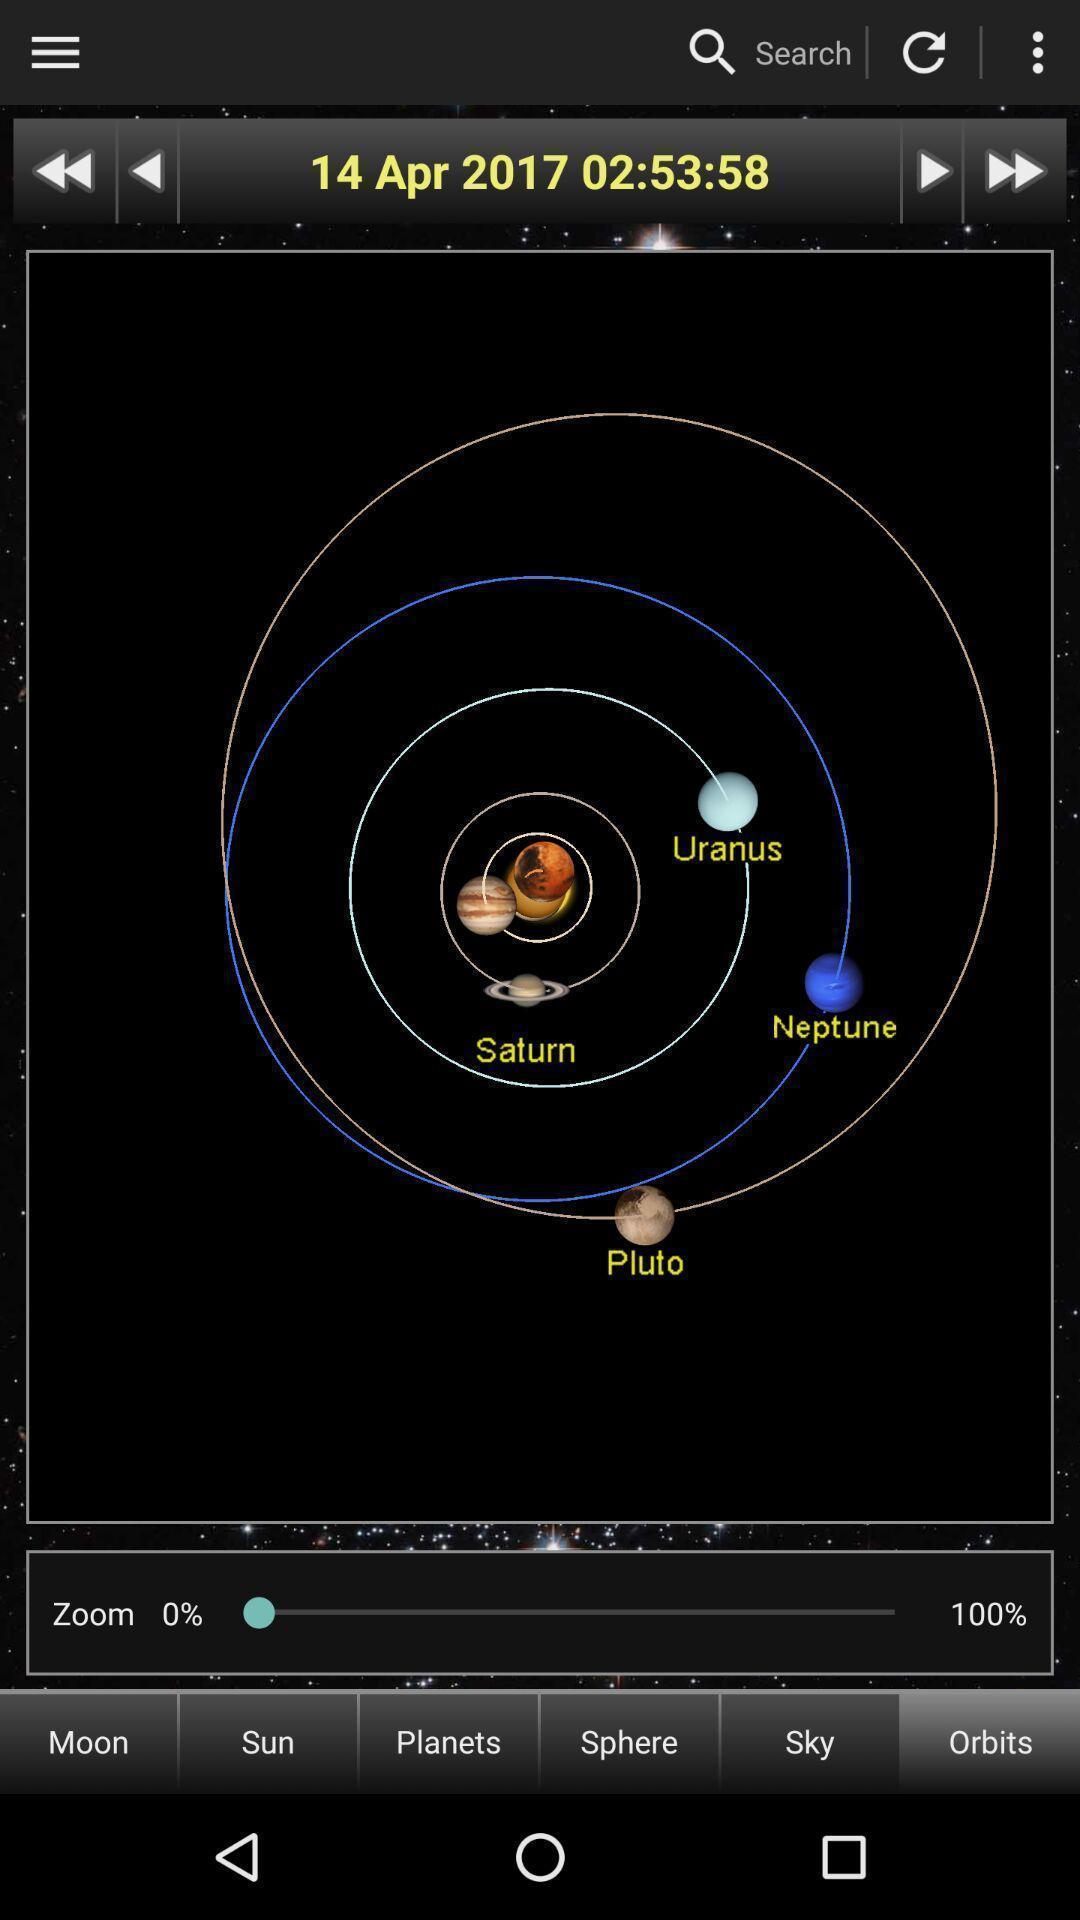What is the overall content of this screenshot? Solar system and moon phase. 